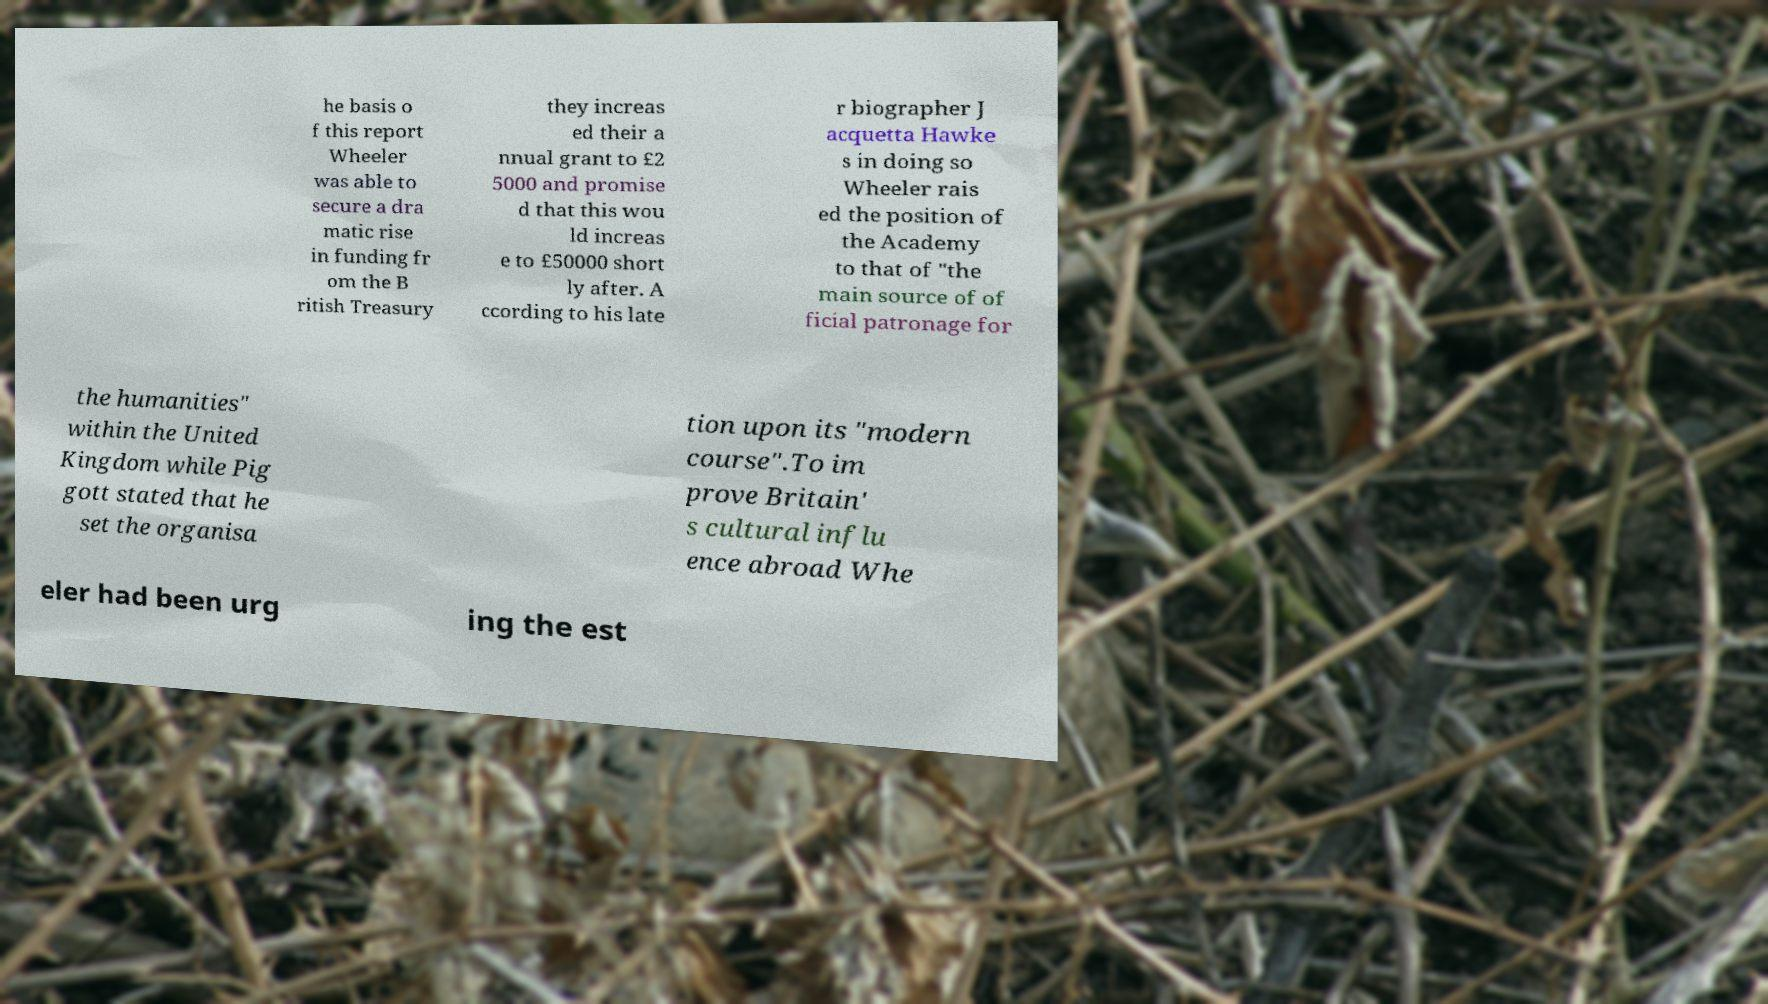What messages or text are displayed in this image? I need them in a readable, typed format. he basis o f this report Wheeler was able to secure a dra matic rise in funding fr om the B ritish Treasury they increas ed their a nnual grant to £2 5000 and promise d that this wou ld increas e to £50000 short ly after. A ccording to his late r biographer J acquetta Hawke s in doing so Wheeler rais ed the position of the Academy to that of "the main source of of ficial patronage for the humanities" within the United Kingdom while Pig gott stated that he set the organisa tion upon its "modern course".To im prove Britain' s cultural influ ence abroad Whe eler had been urg ing the est 